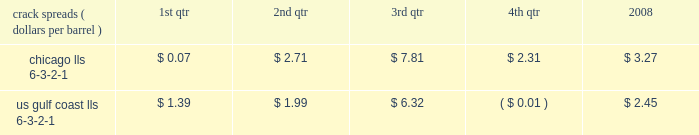Our refining and wholesale marketing gross margin is the difference between the prices of refined products sold and the costs of crude oil and other charge and blendstocks refined , including the costs to transport these inputs to our refineries , the costs of purchased products and manufacturing expenses , including depreciation .
The crack spread is a measure of the difference between market prices for refined products and crude oil , commonly used by the industry as an indicator of the impact of price on the refining margin .
Crack spreads can fluctuate significantly , particularly when prices of refined products do not move in the same relationship as the cost of crude oil .
As a performance benchmark and a comparison with other industry participants , we calculate midwest ( chicago ) and u.s .
Gulf coast crack spreads that we feel most closely track our operations and slate of products .
Posted light louisiana sweet ( 201clls 201d ) prices and a 6-3-2-1 ratio of products ( 6 barrels of crude oil producing 3 barrels of gasoline , 2 barrels of distillate and 1 barrel of residual fuel ) are used for the crack spread calculation .
The table lists calculated average crack spreads by quarter for the midwest ( chicago ) and gulf coast markets in 2008 .
Crack spreads ( dollars per barrel ) 1st qtr 2nd qtr 3rd qtr 4th qtr 2008 .
In addition to the market changes indicated by the crack spreads , our refining and wholesale marketing gross margin is impacted by factors such as the types of crude oil and other charge and blendstocks processed , the selling prices realized for refined products , the impact of commodity derivative instruments used to mitigate price risk and the cost of purchased products for resale .
We process significant amounts of sour crude oil which can enhance our profitability compared to certain of our competitors , as sour crude oil typically can be purchased at a discount to sweet crude oil .
Finally , our refining and wholesale marketing gross margin is impacted by changes in manufacturing costs , which are primarily driven by the level of maintenance activities at the refineries and the price of purchased natural gas used for plant fuel .
Our 2008 refining and wholesale marketing gross margin was the key driver of the 43 percent decrease in rm&t segment income when compared to 2007 .
Our average refining and wholesale marketing gross margin per gallon decreased 37 percent , to 11.66 cents in 2008 from 18.48 cents in 2007 , primarily due to the significant and rapid increases in crude oil prices early in 2008 and lagging wholesale price realizations .
Our retail marketing gross margin for gasoline and distillates , which is the difference between the ultimate price paid by consumers and the cost of refined products , including secondary transportation and consumer excise taxes , also impacts rm&t segment profitability .
While on average demand has been increasing for several years , there are numerous factors including local competition , seasonal demand fluctuations , the available wholesale supply , the level of economic activity in our marketing areas and weather conditions that impact gasoline and distillate demand throughout the year .
In 2008 , demand began to drop due to the combination of significant increases in retail petroleum prices and a broad slowdown in general activity .
The gross margin on merchandise sold at retail outlets has historically been more constant .
The profitability of our pipeline transportation operations is primarily dependent on the volumes shipped through our crude oil and refined products pipelines .
The volume of crude oil that we transport is directly affected by the supply of , and refiner demand for , crude oil in the markets served directly by our crude oil pipelines .
Key factors in this supply and demand balance are the production levels of crude oil by producers , the availability and cost of alternative modes of transportation , and refinery and transportation system maintenance levels .
The volume of refined products that we transport is directly affected by the production levels of , and user demand for , refined products in the markets served by our refined product pipelines .
In most of our markets , demand for gasoline peaks during the summer and declines during the fall and winter months , whereas distillate demand is more ratable throughout the year .
As with crude oil , other transportation alternatives and system maintenance levels influence refined product movements .
Integrated gas our integrated gas strategy is to link stranded natural gas resources with areas where a supply gap is emerging due to declining production and growing demand .
Our integrated gas operations include marketing and transportation of products manufactured from natural gas , such as lng and methanol , primarily in the u.s. , europe and west africa .
Our most significant lng investment is our 60 percent ownership in a production facility in equatorial guinea , which sells lng under a long-term contract at prices tied to henry hub natural gas prices .
In 2008 , its .
What was the average crack spread for us gulf coast lls 6-3-2-1 in the first and second quarter of 2008? 
Computations: ((1.39 + 1.99) / 2)
Answer: 1.69. 